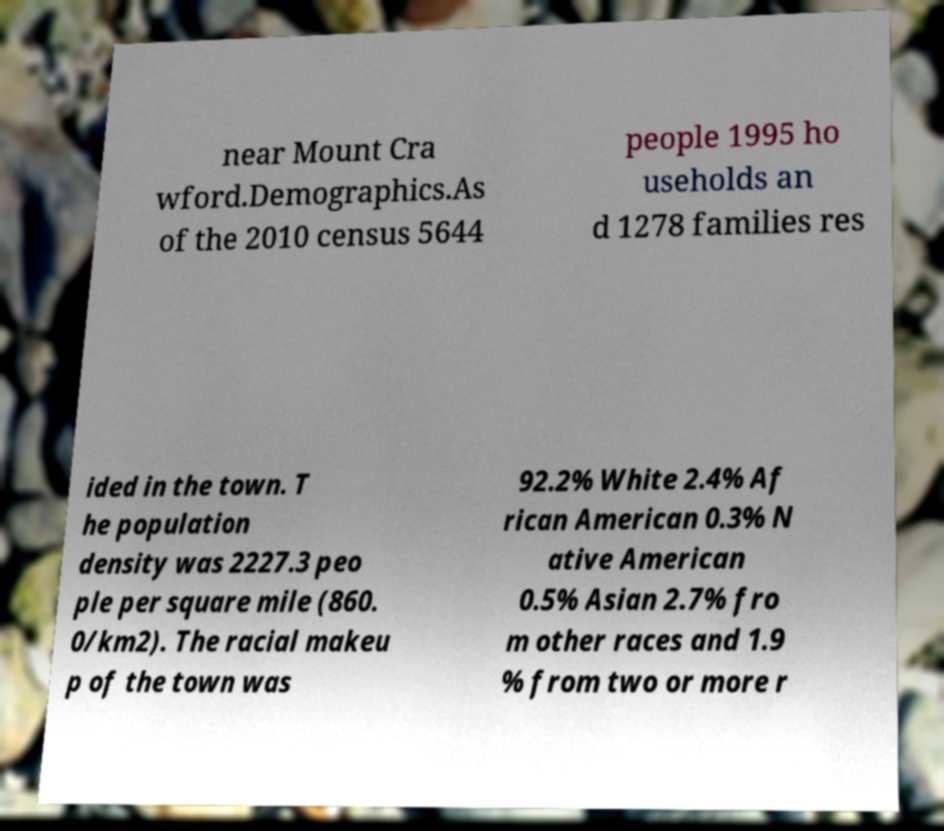What messages or text are displayed in this image? I need them in a readable, typed format. near Mount Cra wford.Demographics.As of the 2010 census 5644 people 1995 ho useholds an d 1278 families res ided in the town. T he population density was 2227.3 peo ple per square mile (860. 0/km2). The racial makeu p of the town was 92.2% White 2.4% Af rican American 0.3% N ative American 0.5% Asian 2.7% fro m other races and 1.9 % from two or more r 